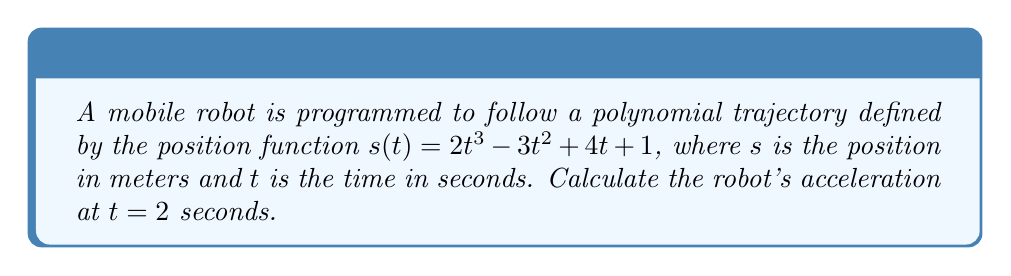Show me your answer to this math problem. To find the acceleration of the robot, we need to follow these steps:

1) The position function is given as:
   $s(t) = 2t^3 - 3t^2 + 4t + 1$

2) To find the velocity function, we need to differentiate $s(t)$ with respect to $t$:
   $$v(t) = \frac{d}{dt}s(t) = 6t^2 - 6t + 4$$

3) To find the acceleration function, we need to differentiate $v(t)$ with respect to $t$:
   $$a(t) = \frac{d}{dt}v(t) = 12t - 6$$

4) Now that we have the acceleration function, we can calculate the acceleration at $t = 2$ seconds:
   $$a(2) = 12(2) - 6 = 24 - 6 = 18$$

Therefore, the acceleration of the robot at $t = 2$ seconds is 18 m/s².
Answer: $18$ m/s² 